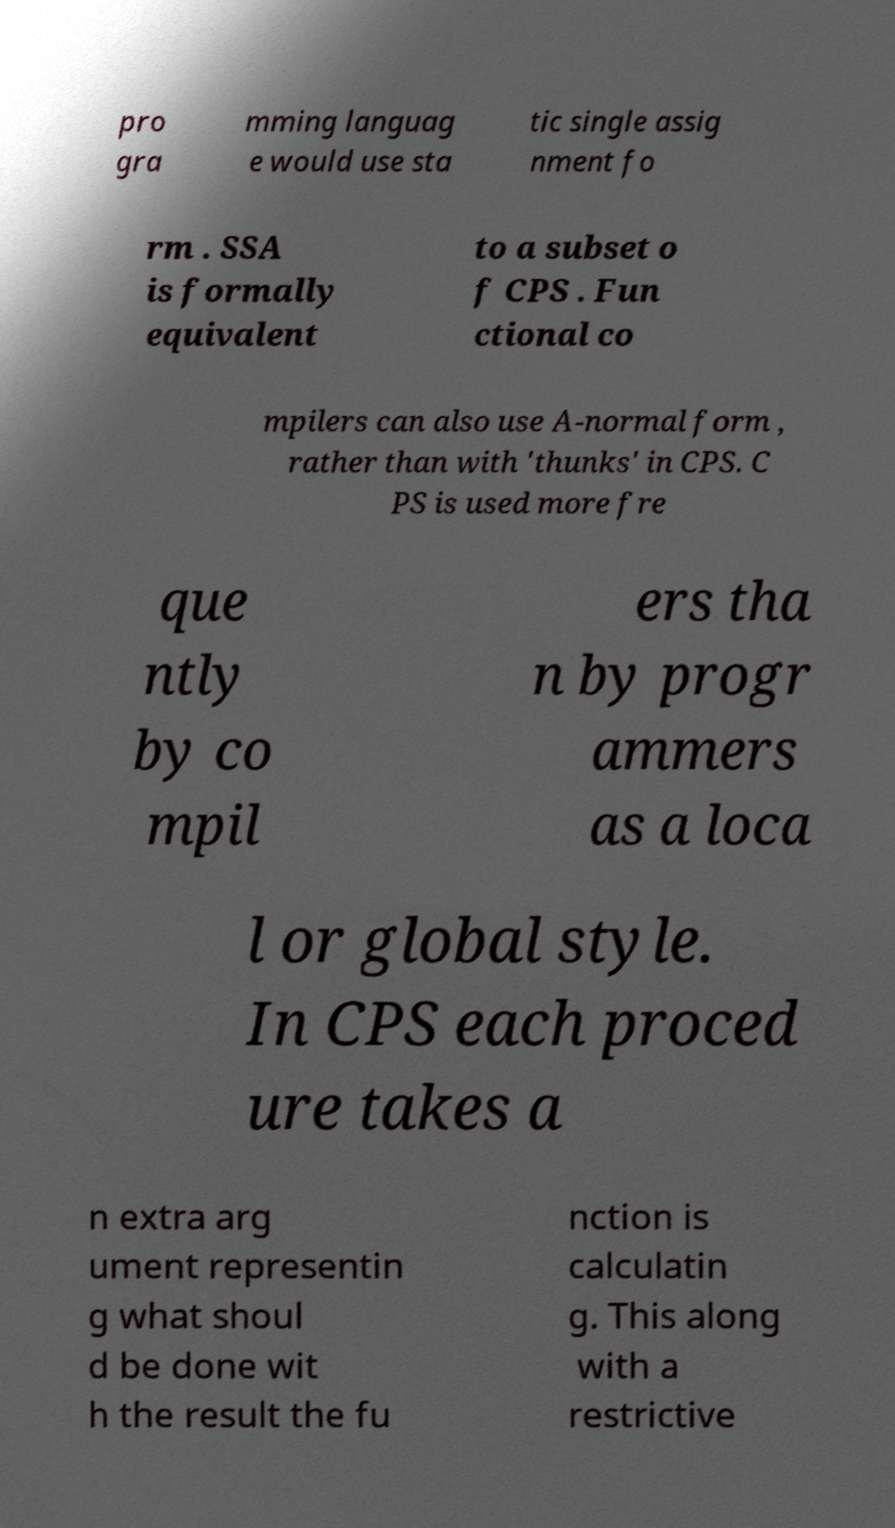I need the written content from this picture converted into text. Can you do that? pro gra mming languag e would use sta tic single assig nment fo rm . SSA is formally equivalent to a subset o f CPS . Fun ctional co mpilers can also use A-normal form , rather than with 'thunks' in CPS. C PS is used more fre que ntly by co mpil ers tha n by progr ammers as a loca l or global style. In CPS each proced ure takes a n extra arg ument representin g what shoul d be done wit h the result the fu nction is calculatin g. This along with a restrictive 